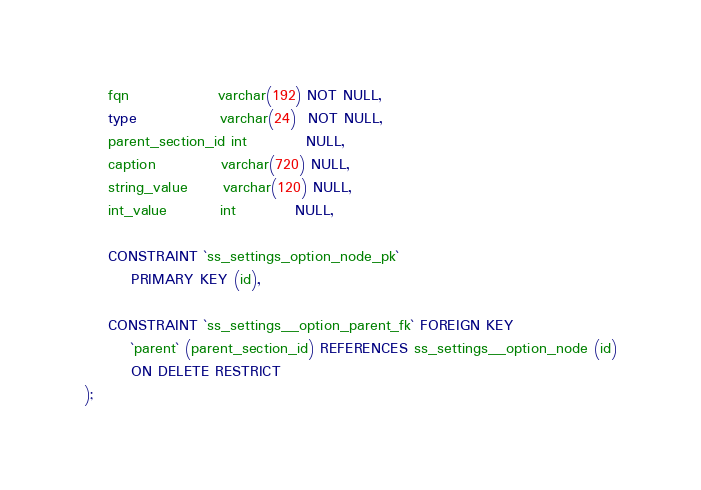Convert code to text. <code><loc_0><loc_0><loc_500><loc_500><_SQL_>    fqn               varchar(192) NOT NULL,
    type              varchar(24)  NOT NULL,
    parent_section_id int          NULL,
    caption           varchar(720) NULL,
    string_value      varchar(120) NULL,
    int_value         int          NULL,

    CONSTRAINT `ss_settings_option_node_pk`
        PRIMARY KEY (id),

    CONSTRAINT `ss_settings__option_parent_fk` FOREIGN KEY
        `parent` (parent_section_id) REFERENCES ss_settings__option_node (id)
        ON DELETE RESTRICT
);
</code> 